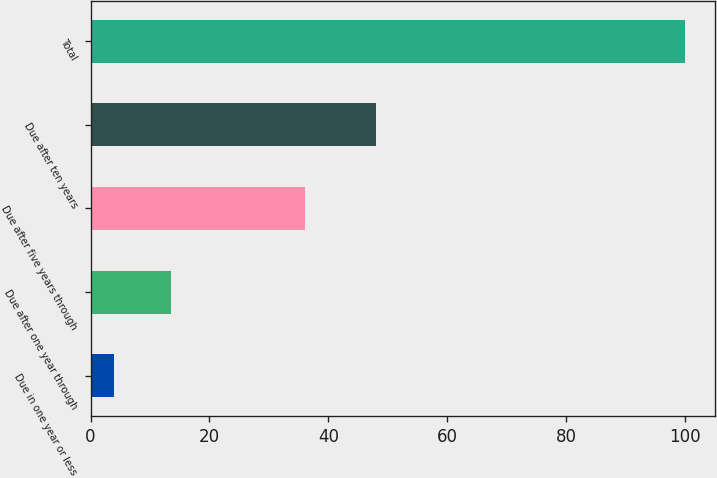Convert chart. <chart><loc_0><loc_0><loc_500><loc_500><bar_chart><fcel>Due in one year or less<fcel>Due after one year through<fcel>Due after five years through<fcel>Due after ten years<fcel>Total<nl><fcel>4<fcel>13.6<fcel>36<fcel>48<fcel>100<nl></chart> 